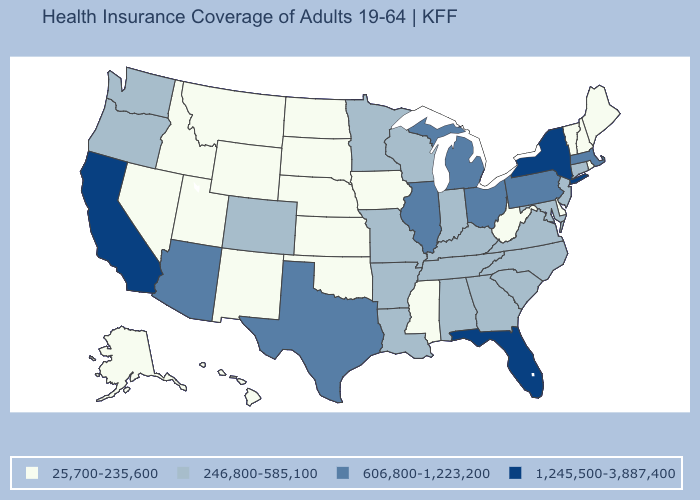Which states have the highest value in the USA?
Concise answer only. California, Florida, New York. Does Illinois have a higher value than Montana?
Write a very short answer. Yes. What is the value of Montana?
Keep it brief. 25,700-235,600. Does Maryland have the same value as Wisconsin?
Answer briefly. Yes. How many symbols are there in the legend?
Short answer required. 4. Name the states that have a value in the range 246,800-585,100?
Be succinct. Alabama, Arkansas, Colorado, Connecticut, Georgia, Indiana, Kentucky, Louisiana, Maryland, Minnesota, Missouri, New Jersey, North Carolina, Oregon, South Carolina, Tennessee, Virginia, Washington, Wisconsin. Among the states that border Missouri , which have the lowest value?
Short answer required. Iowa, Kansas, Nebraska, Oklahoma. Name the states that have a value in the range 25,700-235,600?
Quick response, please. Alaska, Delaware, Hawaii, Idaho, Iowa, Kansas, Maine, Mississippi, Montana, Nebraska, Nevada, New Hampshire, New Mexico, North Dakota, Oklahoma, Rhode Island, South Dakota, Utah, Vermont, West Virginia, Wyoming. What is the value of Florida?
Keep it brief. 1,245,500-3,887,400. Does the first symbol in the legend represent the smallest category?
Quick response, please. Yes. Does Florida have the highest value in the South?
Give a very brief answer. Yes. Name the states that have a value in the range 25,700-235,600?
Be succinct. Alaska, Delaware, Hawaii, Idaho, Iowa, Kansas, Maine, Mississippi, Montana, Nebraska, Nevada, New Hampshire, New Mexico, North Dakota, Oklahoma, Rhode Island, South Dakota, Utah, Vermont, West Virginia, Wyoming. Does New Hampshire have a higher value than Rhode Island?
Answer briefly. No. Which states have the lowest value in the USA?
Concise answer only. Alaska, Delaware, Hawaii, Idaho, Iowa, Kansas, Maine, Mississippi, Montana, Nebraska, Nevada, New Hampshire, New Mexico, North Dakota, Oklahoma, Rhode Island, South Dakota, Utah, Vermont, West Virginia, Wyoming. Name the states that have a value in the range 1,245,500-3,887,400?
Write a very short answer. California, Florida, New York. 